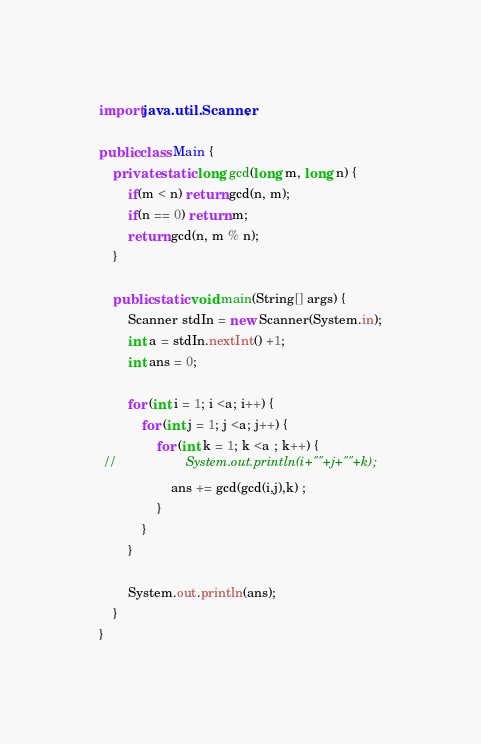<code> <loc_0><loc_0><loc_500><loc_500><_Java_>import java.util.Scanner;

public class Main {
    private static long gcd(long m, long n) {
        if(m < n) return gcd(n, m);
        if(n == 0) return m;
        return gcd(n, m % n);
    }

    public static void main(String[] args) {
        Scanner stdIn = new Scanner(System.in);
        int a = stdIn.nextInt() +1;
        int ans = 0;

        for (int i = 1; i <a; i++) {
            for (int j = 1; j <a; j++) {
                for (int k = 1; k <a ; k++) {
 //                   System.out.println(i+""+j+""+k);
                    ans += gcd(gcd(i,j),k) ;
                }
            }
        }

        System.out.println(ans);
    }
}
</code> 